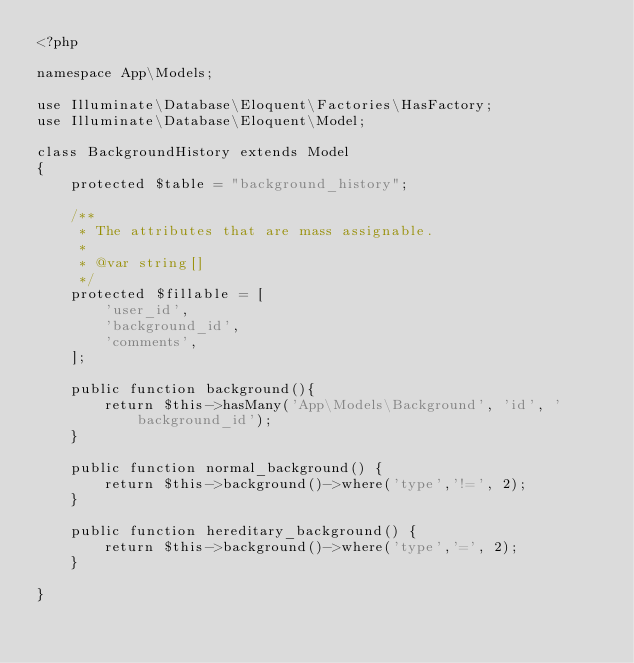<code> <loc_0><loc_0><loc_500><loc_500><_PHP_><?php

namespace App\Models;

use Illuminate\Database\Eloquent\Factories\HasFactory;
use Illuminate\Database\Eloquent\Model;

class BackgroundHistory extends Model
{
    protected $table = "background_history";

    /**
     * The attributes that are mass assignable.
     *
     * @var string[]
     */
    protected $fillable = [
        'user_id',
        'background_id',
        'comments',
    ];

    public function background(){
        return $this->hasMany('App\Models\Background', 'id', 'background_id');
    }

    public function normal_background() {
        return $this->background()->where('type','!=', 2);
    }

    public function hereditary_background() {
        return $this->background()->where('type','=', 2);
    }
    
}</code> 